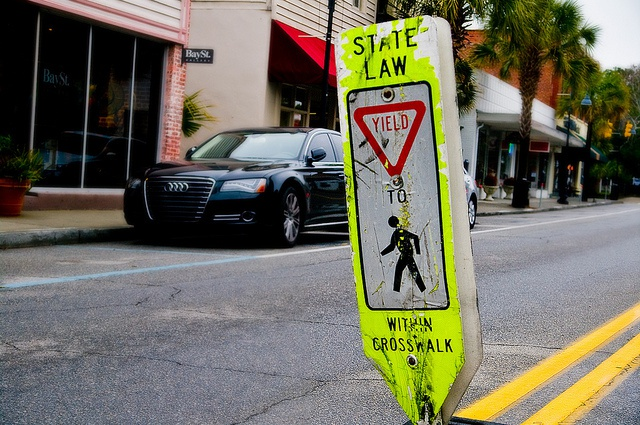Describe the objects in this image and their specific colors. I can see car in black, gray, darkgray, and lightgray tones, potted plant in black, maroon, and darkgreen tones, car in black, darkgray, and lightgray tones, potted plant in black, gray, darkgreen, and darkgray tones, and car in black, blue, navy, and gray tones in this image. 